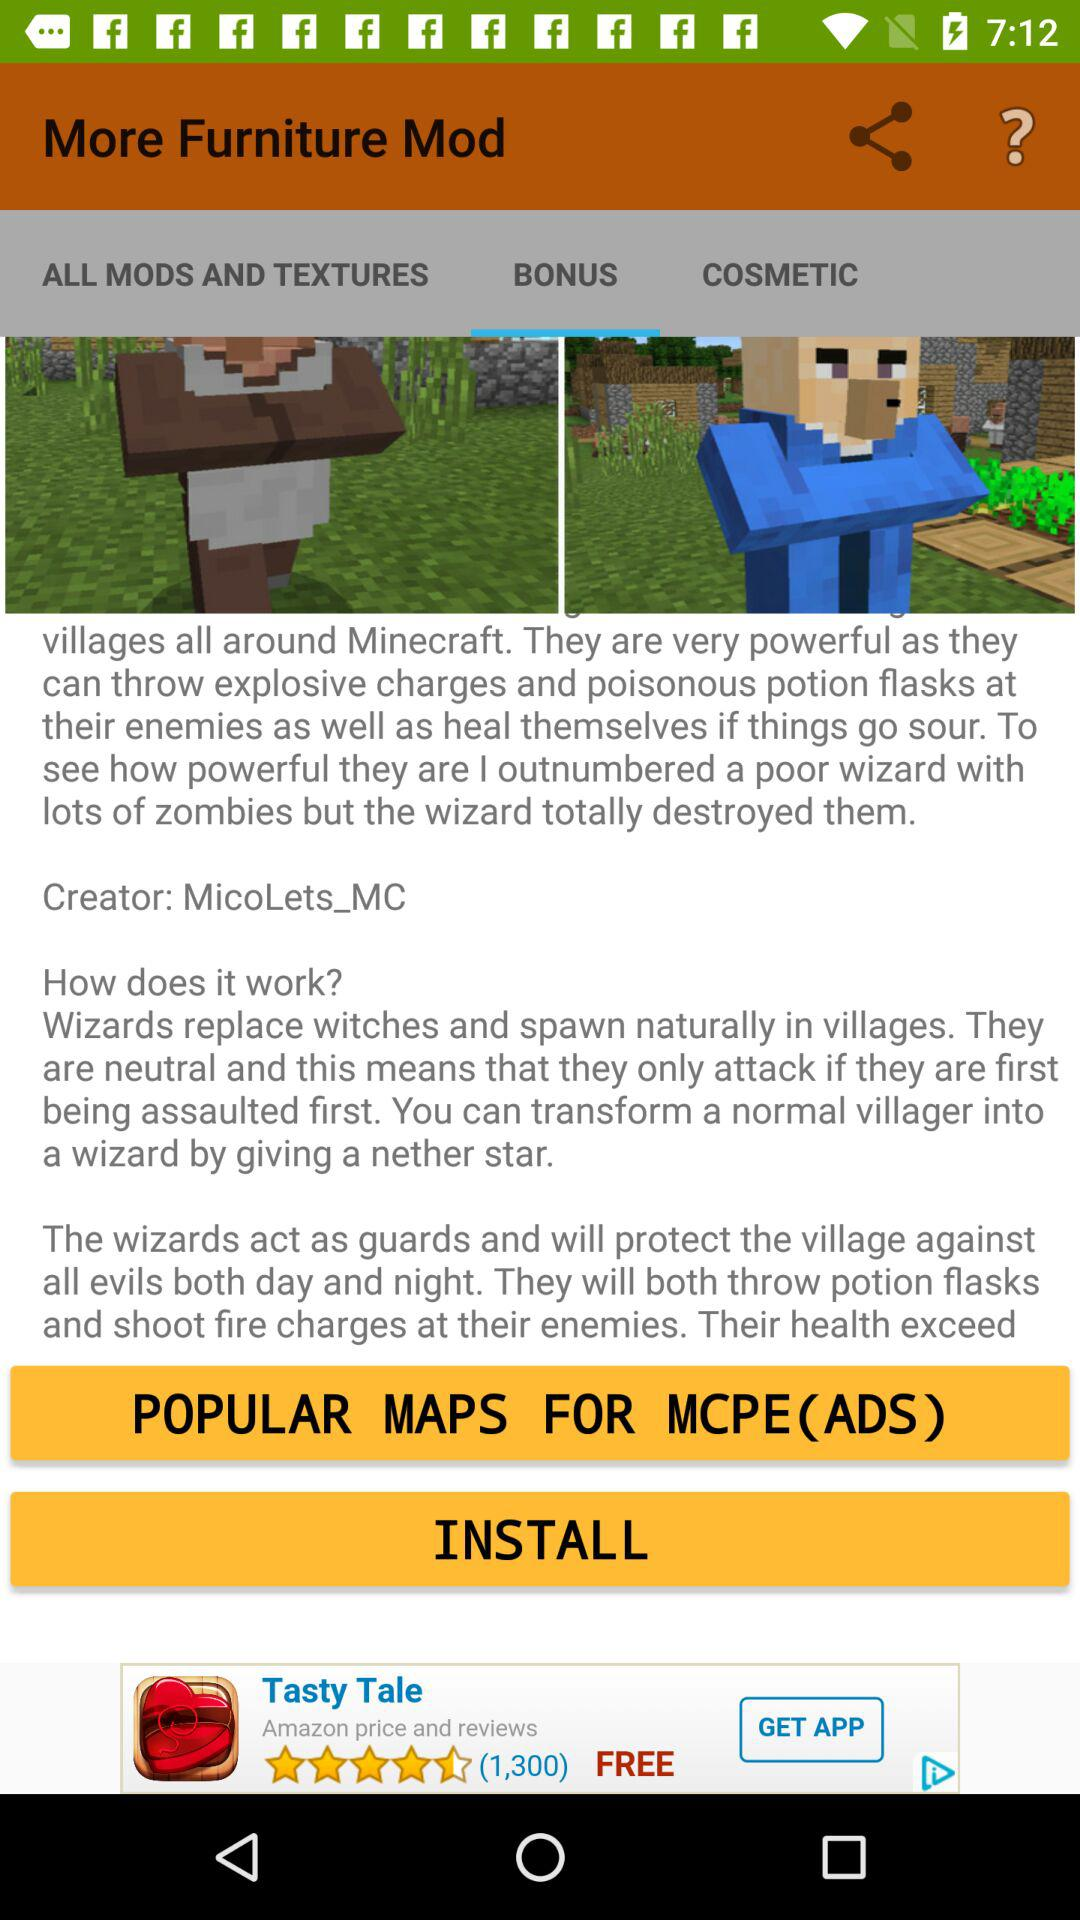Which tab is selected? The selected tab is "BONUS". 